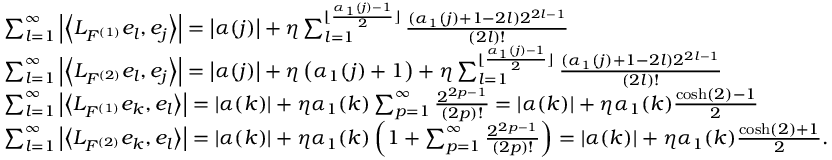<formula> <loc_0><loc_0><loc_500><loc_500>\begin{array} { l } { \sum _ { l = 1 } ^ { \infty } \left | \left \langle L _ { F ^ { ( 1 ) } } e _ { l } , e _ { j } \right \rangle \right | = \left | \alpha ( j ) \right | + \eta \sum _ { l = 1 } ^ { \lfloor \frac { \alpha _ { 1 } ( j ) - 1 } { 2 } \rfloor } \frac { ( \alpha _ { 1 } ( j ) + 1 - 2 l ) 2 ^ { 2 l - 1 } } { ( 2 l ) ! } } \\ { \sum _ { l = 1 } ^ { \infty } \left | \left \langle L _ { F ^ { ( 2 ) } } e _ { l } , e _ { j } \right \rangle \right | = \left | \alpha ( j ) \right | + \eta \left ( \alpha _ { 1 } ( j ) + 1 \right ) + \eta \sum _ { l = 1 } ^ { \lfloor \frac { \alpha _ { 1 } ( j ) - 1 } { 2 } \rfloor } \frac { ( \alpha _ { 1 } ( j ) + 1 - 2 l ) 2 ^ { 2 l - 1 } } { ( 2 l ) ! } } \\ { \sum _ { l = 1 } ^ { \infty } \left | \left \langle L _ { F ^ { ( 1 ) } } e _ { k } , e _ { l } \right \rangle \right | = \left | \alpha ( k ) \right | + \eta \alpha _ { 1 } ( k ) \sum _ { p = 1 } ^ { \infty } \frac { 2 ^ { 2 p - 1 } } { ( 2 p ) ! } = \left | \alpha ( k ) \right | + \eta \alpha _ { 1 } ( k ) \frac { \cosh ( 2 ) - 1 } { 2 } } \\ { \sum _ { l = 1 } ^ { \infty } \left | \left \langle L _ { F ^ { ( 2 ) } } e _ { k } , e _ { l } \right \rangle \right | = \left | \alpha ( k ) \right | + \eta \alpha _ { 1 } ( k ) \left ( 1 + \sum _ { p = 1 } ^ { \infty } \frac { 2 ^ { 2 p - 1 } } { ( 2 p ) ! } \right ) = \left | \alpha ( k ) \right | + \eta \alpha _ { 1 } ( k ) \frac { \cosh ( 2 ) + 1 } { 2 } . } \end{array}</formula> 